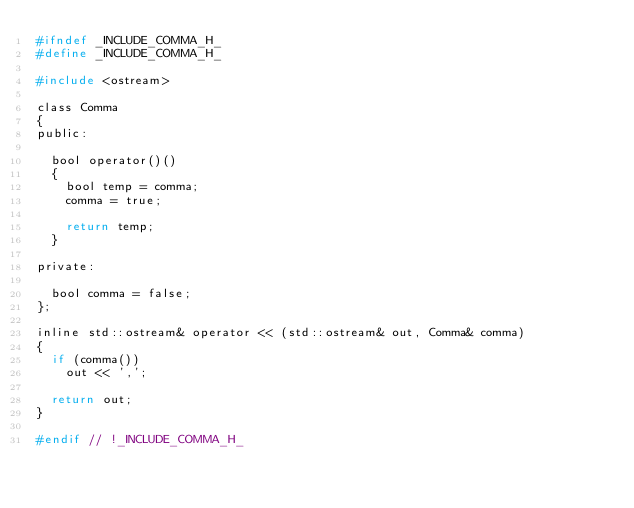Convert code to text. <code><loc_0><loc_0><loc_500><loc_500><_C_>#ifndef _INCLUDE_COMMA_H_
#define _INCLUDE_COMMA_H_

#include <ostream>

class Comma
{
public:

  bool operator()()
  {
    bool temp = comma;
    comma = true;

    return temp;
  }

private:

  bool comma = false;
};

inline std::ostream& operator << (std::ostream& out, Comma& comma)
{
  if (comma())
    out << ',';

  return out;
}

#endif // !_INCLUDE_COMMA_H_

</code> 